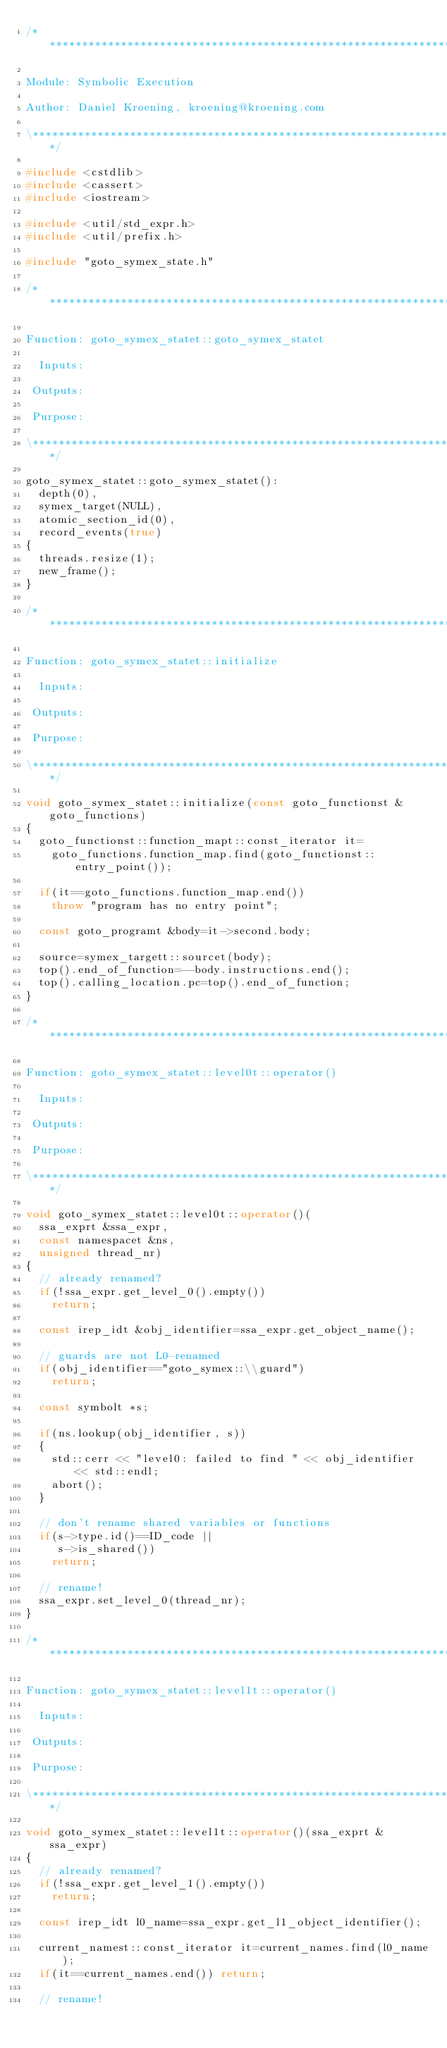<code> <loc_0><loc_0><loc_500><loc_500><_C++_>/*******************************************************************\

Module: Symbolic Execution

Author: Daniel Kroening, kroening@kroening.com

\*******************************************************************/

#include <cstdlib>
#include <cassert>
#include <iostream>

#include <util/std_expr.h>
#include <util/prefix.h>

#include "goto_symex_state.h"

/*******************************************************************\

Function: goto_symex_statet::goto_symex_statet

  Inputs:

 Outputs:

 Purpose:

\*******************************************************************/

goto_symex_statet::goto_symex_statet():
  depth(0),
  symex_target(NULL),
  atomic_section_id(0),
  record_events(true)
{
  threads.resize(1);
  new_frame();
}

/*******************************************************************\

Function: goto_symex_statet::initialize

  Inputs:

 Outputs:

 Purpose:

\*******************************************************************/

void goto_symex_statet::initialize(const goto_functionst &goto_functions)
{
  goto_functionst::function_mapt::const_iterator it=
    goto_functions.function_map.find(goto_functionst::entry_point());

  if(it==goto_functions.function_map.end())
    throw "program has no entry point";

  const goto_programt &body=it->second.body;

  source=symex_targett::sourcet(body);
  top().end_of_function=--body.instructions.end();
  top().calling_location.pc=top().end_of_function;
}

/*******************************************************************\

Function: goto_symex_statet::level0t::operator()

  Inputs:

 Outputs:

 Purpose:

\*******************************************************************/

void goto_symex_statet::level0t::operator()(
  ssa_exprt &ssa_expr,
  const namespacet &ns,
  unsigned thread_nr)
{
  // already renamed?
  if(!ssa_expr.get_level_0().empty())
    return;

  const irep_idt &obj_identifier=ssa_expr.get_object_name();

  // guards are not L0-renamed
  if(obj_identifier=="goto_symex::\\guard")
    return;

  const symbolt *s;

  if(ns.lookup(obj_identifier, s))
  {
    std::cerr << "level0: failed to find " << obj_identifier << std::endl;
    abort();
  }

  // don't rename shared variables or functions
  if(s->type.id()==ID_code ||
     s->is_shared())
    return;

  // rename!
  ssa_expr.set_level_0(thread_nr);
}

/*******************************************************************\

Function: goto_symex_statet::level1t::operator()

  Inputs:

 Outputs:

 Purpose:

\*******************************************************************/

void goto_symex_statet::level1t::operator()(ssa_exprt &ssa_expr)
{
  // already renamed?
  if(!ssa_expr.get_level_1().empty())
    return;

  const irep_idt l0_name=ssa_expr.get_l1_object_identifier();

  current_namest::const_iterator it=current_names.find(l0_name);
  if(it==current_names.end()) return;

  // rename!</code> 